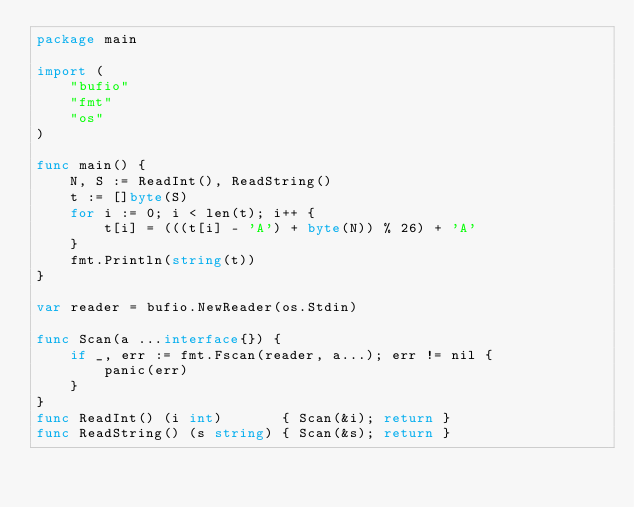Convert code to text. <code><loc_0><loc_0><loc_500><loc_500><_Go_>package main

import (
	"bufio"
	"fmt"
	"os"
)

func main() {
	N, S := ReadInt(), ReadString()
	t := []byte(S)
	for i := 0; i < len(t); i++ {
		t[i] = (((t[i] - 'A') + byte(N)) % 26) + 'A'
	}
	fmt.Println(string(t))
}

var reader = bufio.NewReader(os.Stdin)

func Scan(a ...interface{}) {
	if _, err := fmt.Fscan(reader, a...); err != nil {
		panic(err)
	}
}
func ReadInt() (i int)       { Scan(&i); return }
func ReadString() (s string) { Scan(&s); return }
</code> 